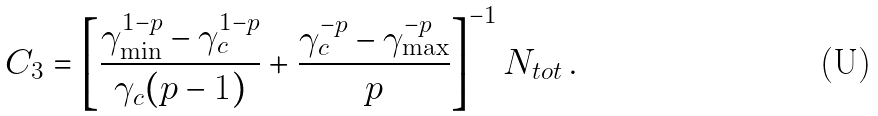Convert formula to latex. <formula><loc_0><loc_0><loc_500><loc_500>C _ { 3 } = \left [ \frac { \gamma _ { \min } ^ { 1 - p } - \gamma _ { c } ^ { 1 - p } } { \gamma _ { c } ( p - 1 ) } + \frac { \gamma _ { c } ^ { - p } - \gamma _ { \max } ^ { - p } } { p } \right ] ^ { - 1 } N _ { t o t } \, .</formula> 